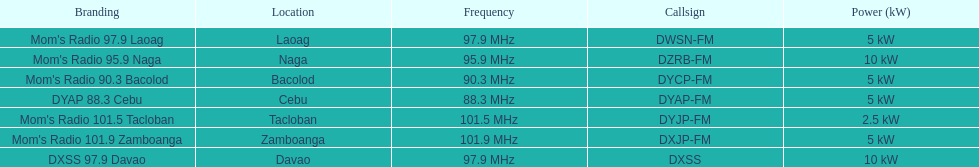What is the last location on this chart? Davao. 